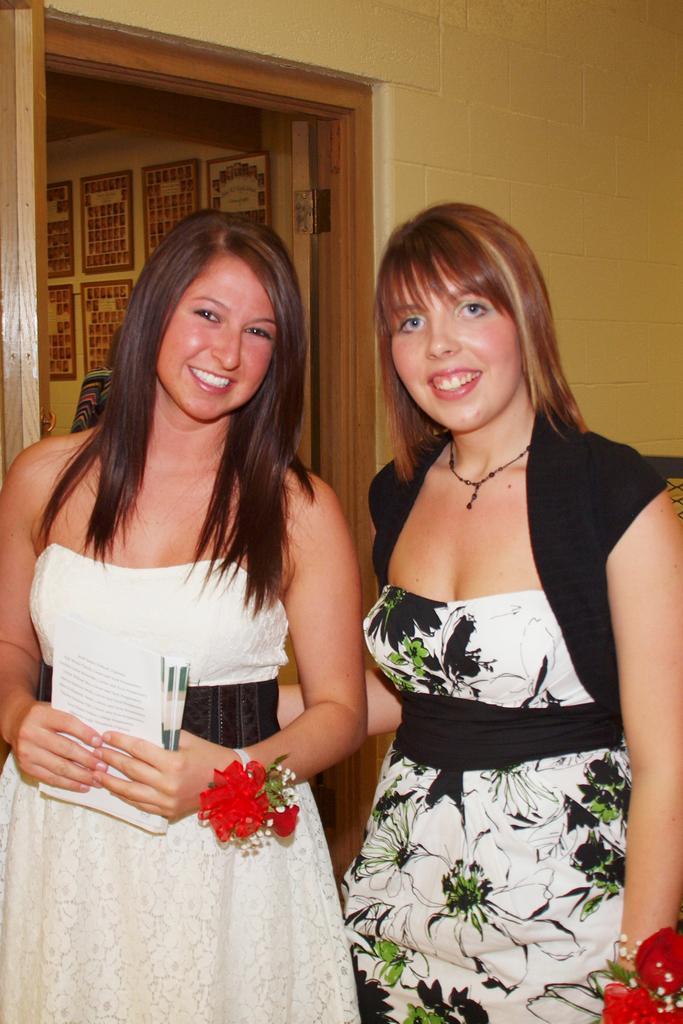Please provide a concise description of this image. In this picture we can see flowers, two women standing and smiling and a woman holding books with her hands and at the back of them we can see frames, walls, person. 